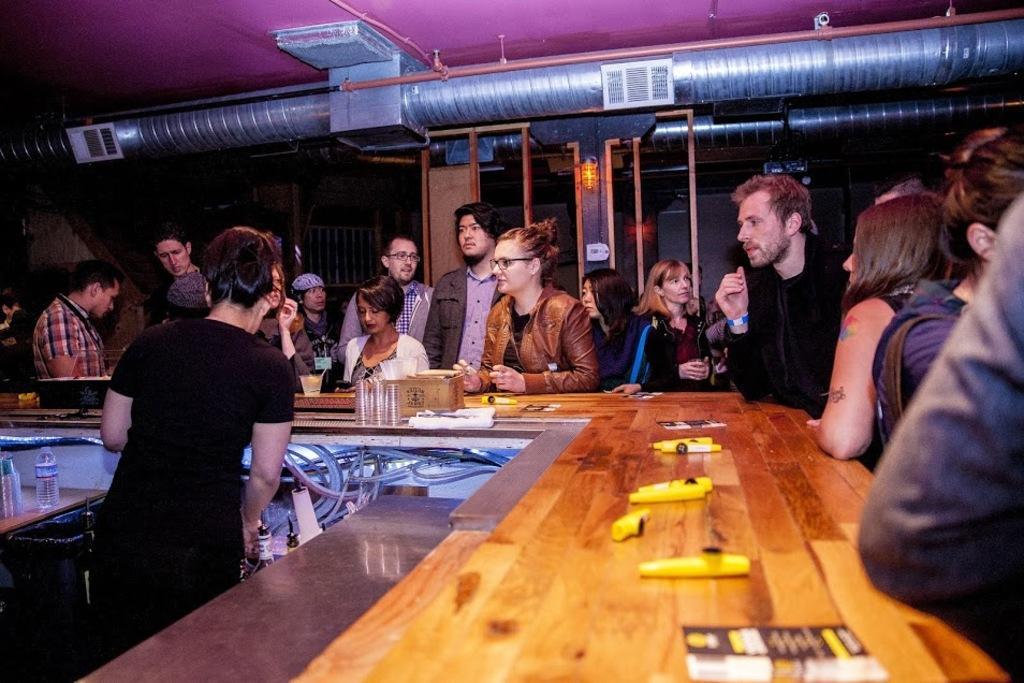Describe this image in one or two sentences. This is the picture where we have group of people standing to the desk on which there are some things and in front of him there is a guy to the other side of the desk. 